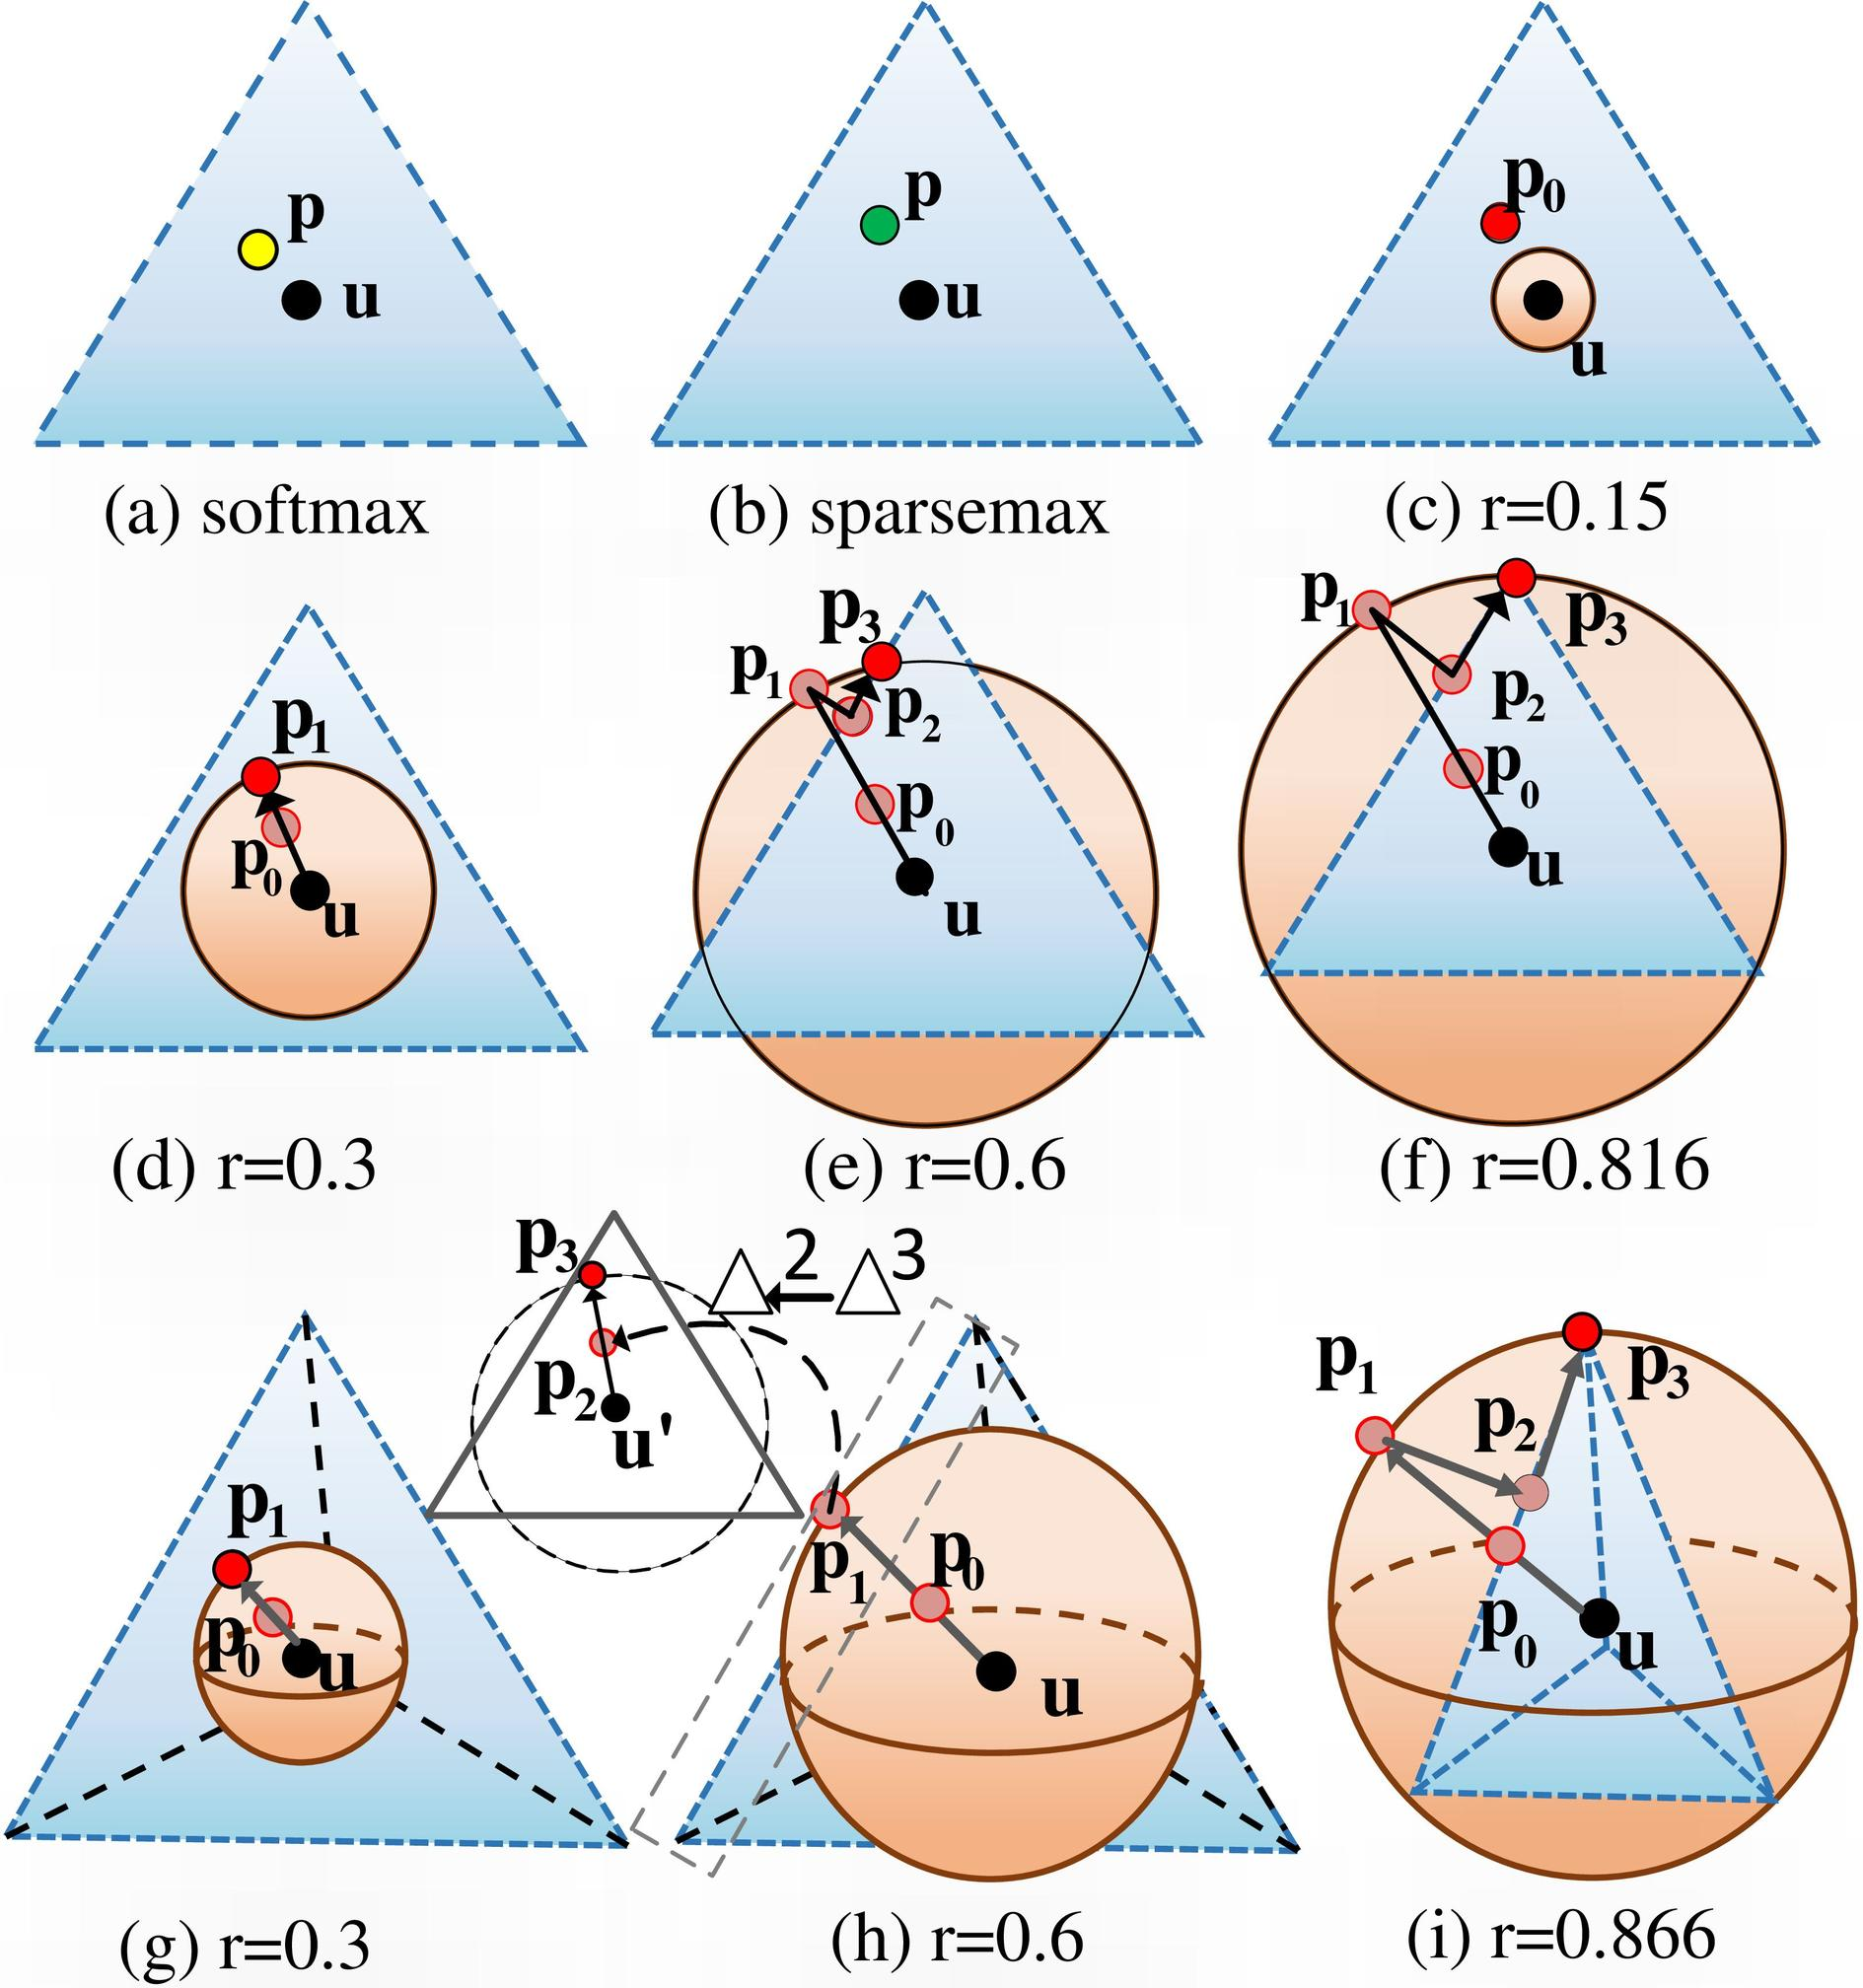Based on the figures (d) to (i), which value of r demonstrates the largest entropic regularization effect on the distribution? A. r=0.15 B. r=0.3 C. r=0.6 D. r=0.816 From the given figures (d) through (i), the entropic regularization effect varies according to the value of r. This effect can be visualized as the spread of the probability distribution around the point u. In figure (f), where r=0.816, we observe that the probability distribution is the most widely dispersed, encompassing a larger area compared to other figures. This extensive spread is indicative of a robust entropic regularization. Therefore, the most significant entropic regularization effect corresponds to an r value of 0.816, making the answer D. 